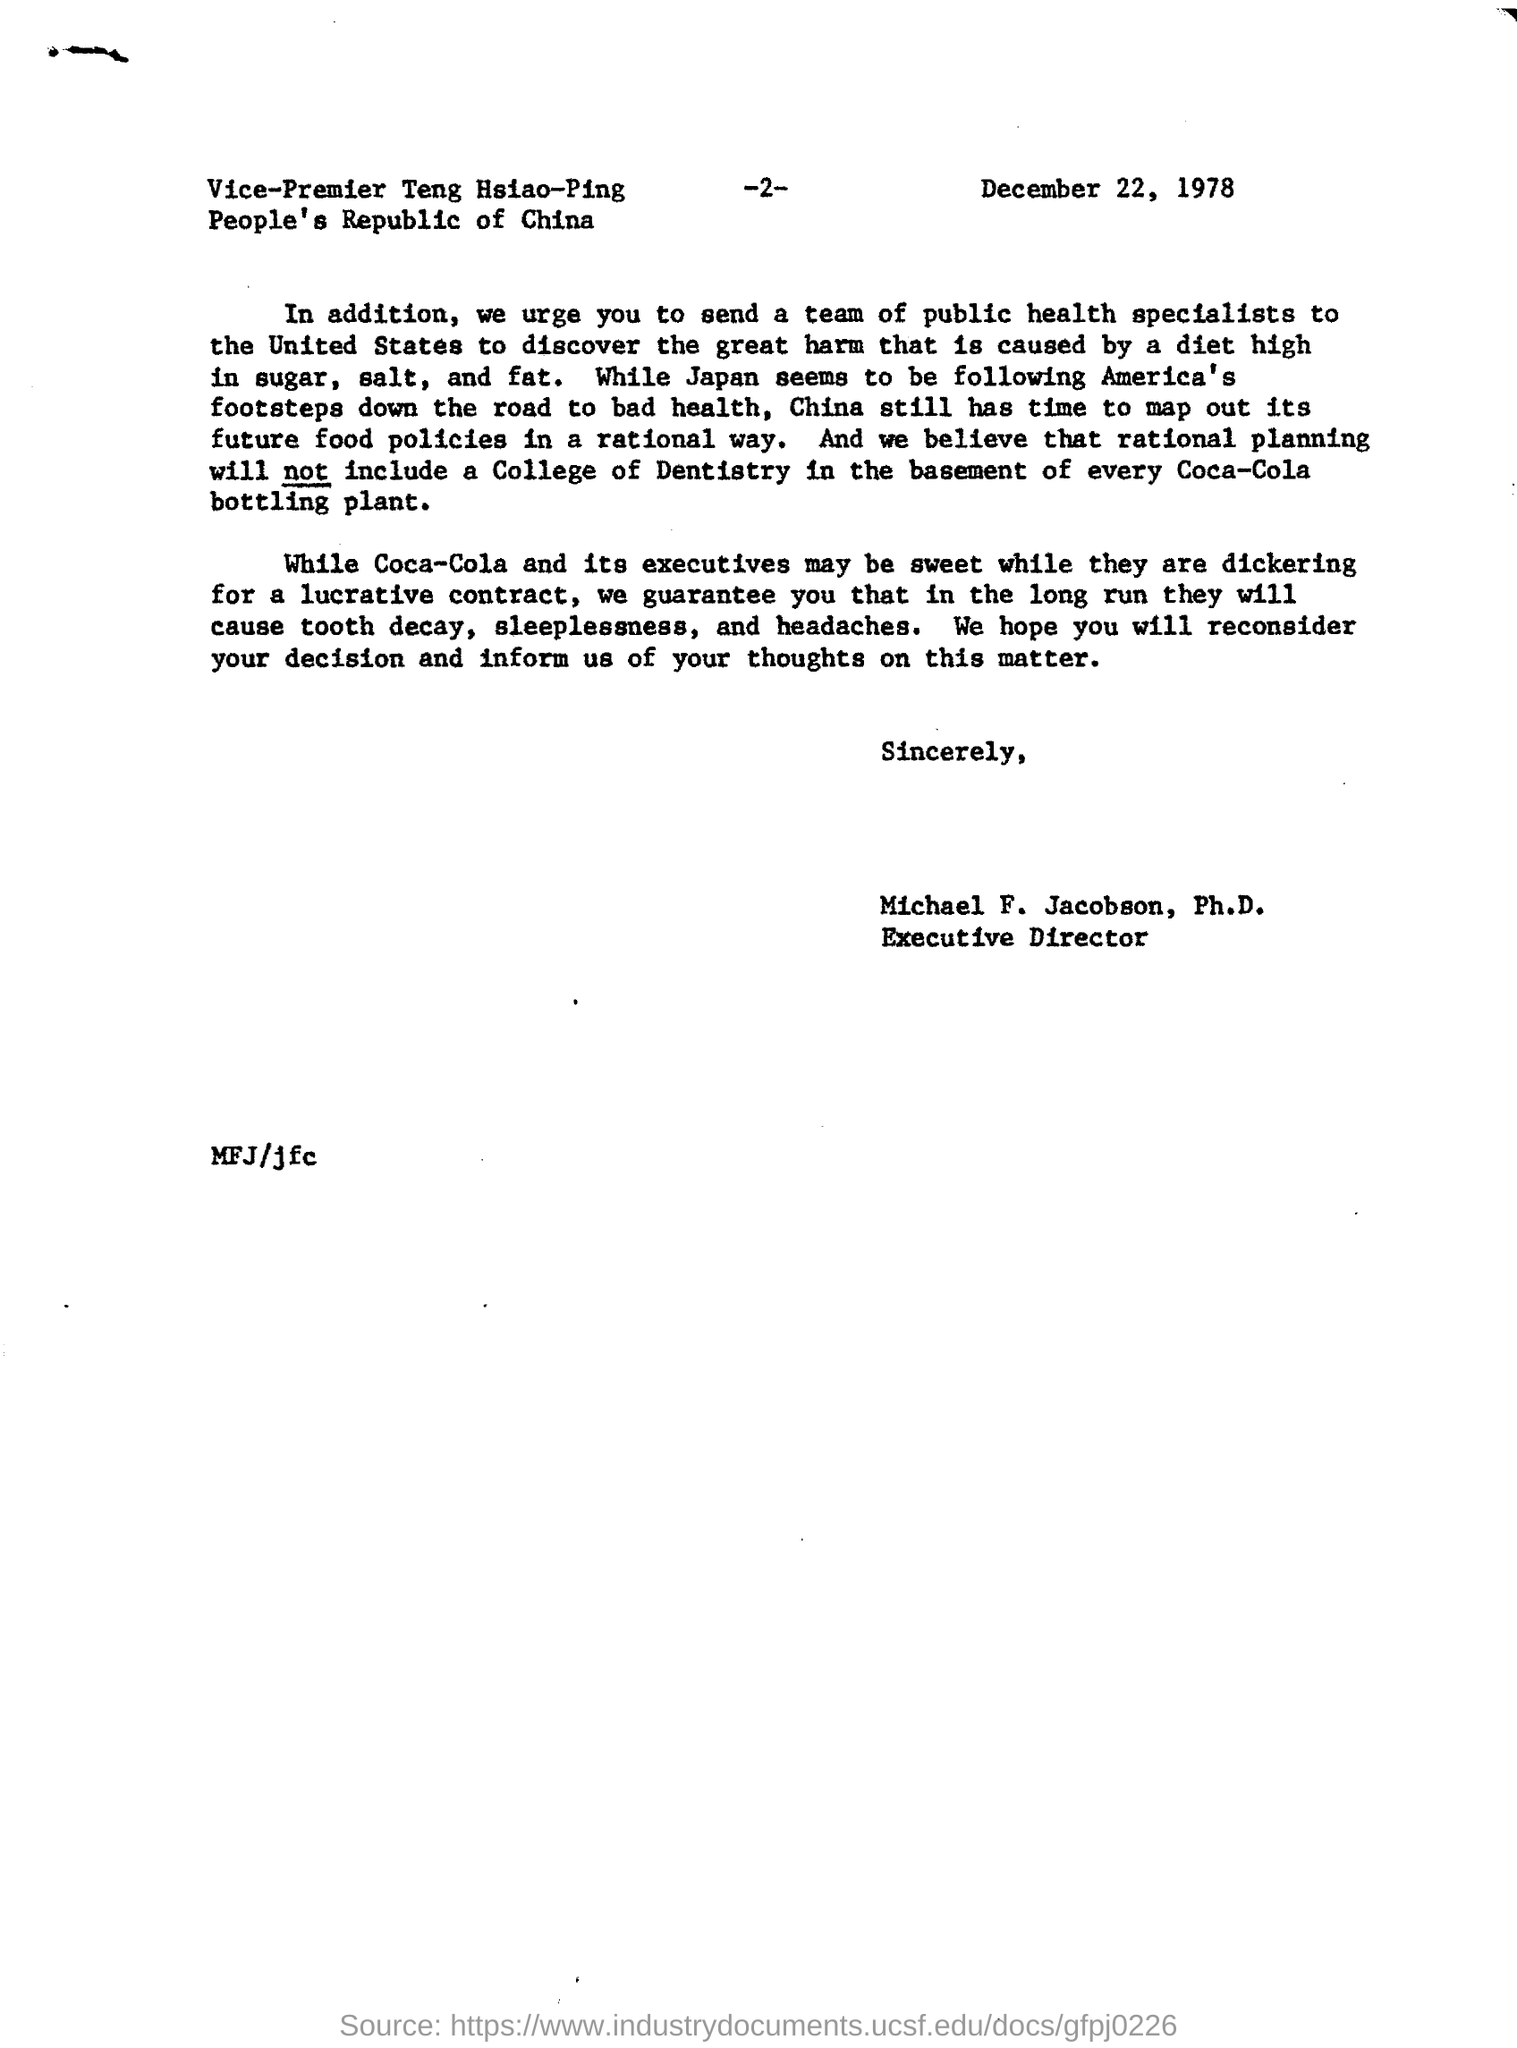Identify some key points in this picture. Japan is following in the footsteps of America, leading to similar actions and policies being taken. 